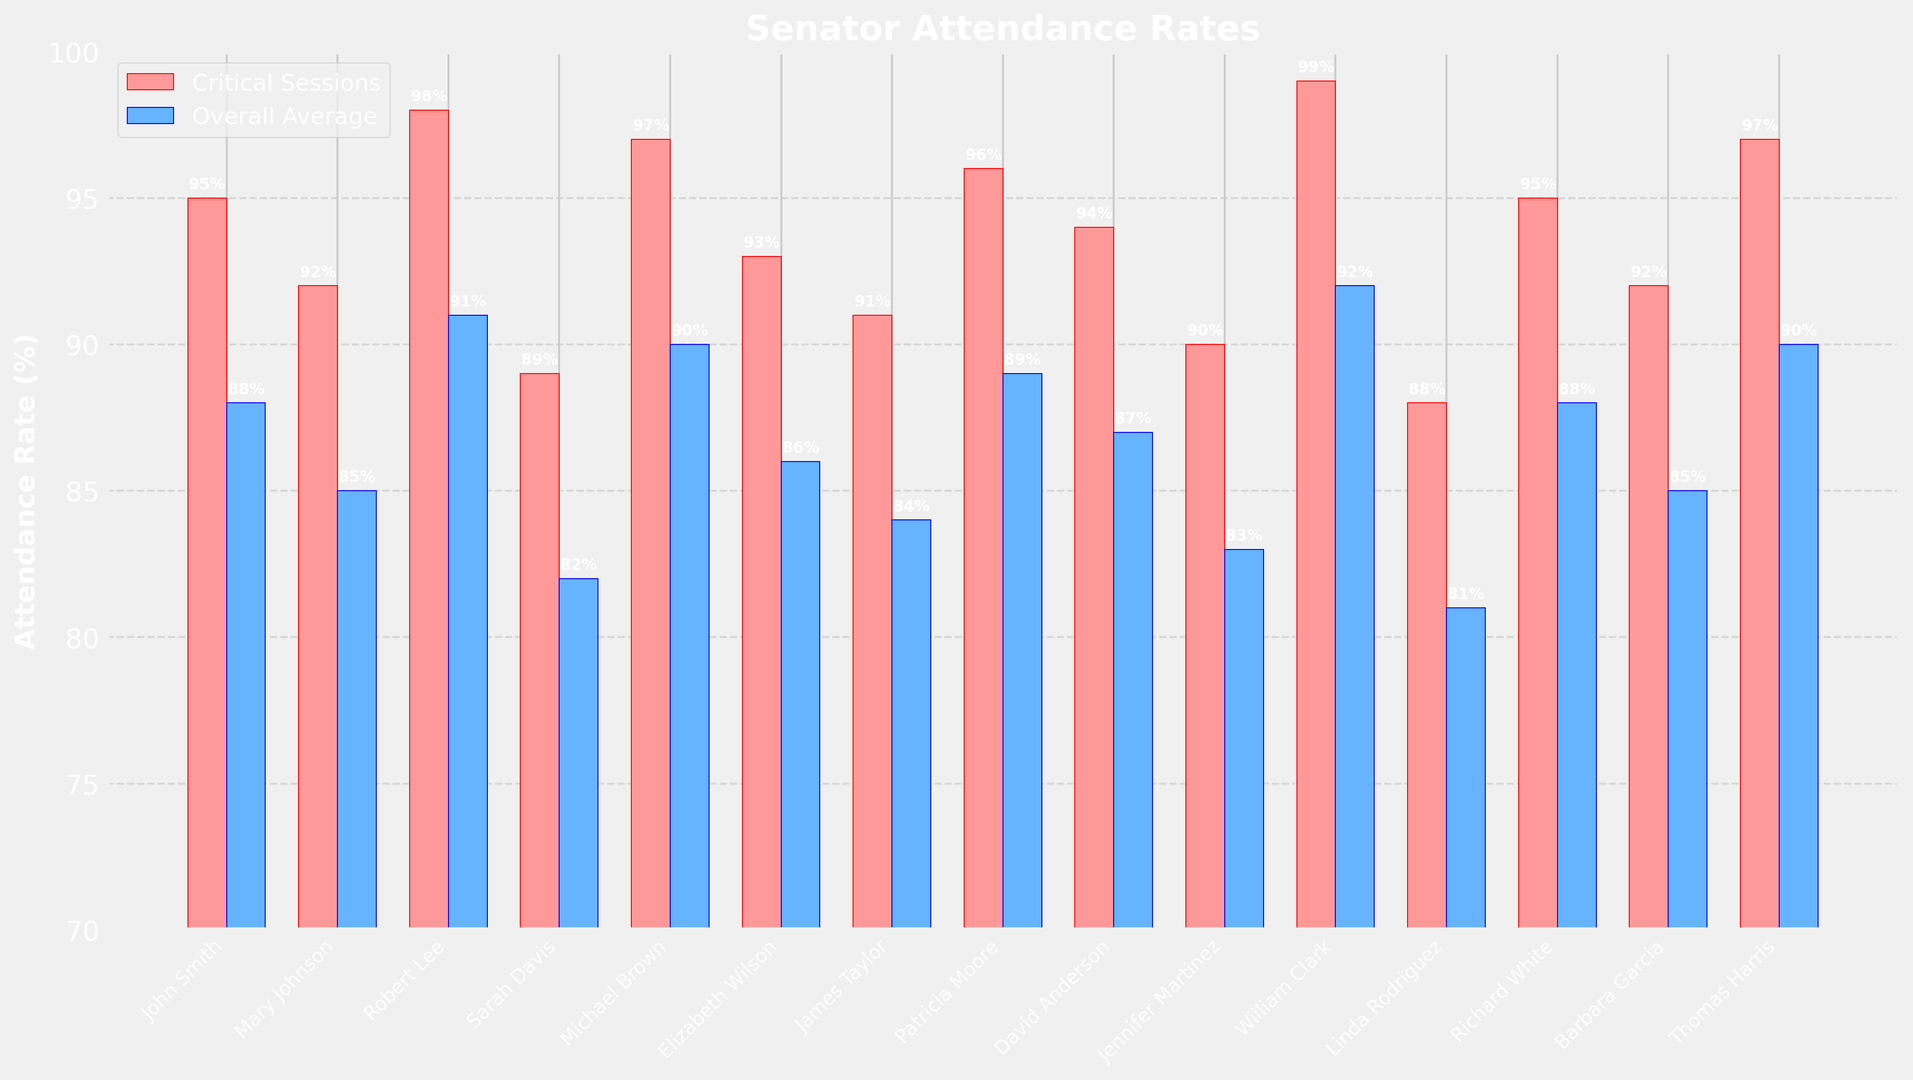Which senator has the highest attendance rate during critical sessions? The bar representing William Clark for critical sessions is the tallest among all the senators, which indicates the highest attendance rate.
Answer: William Clark What is the difference between Robert Lee's attendance rate for critical sessions and overall average? Robert Lee's attendance rate for critical sessions is 98%, and his overall average attendance rate is 91%. The difference is 98% - 91%.
Answer: 7% Who has a lower attendance rate during critical sessions, Jennifer Martinez or Linda Rodriguez? Compare the heights of the bars for Jennifer Martinez and Linda Rodriguez for critical sessions. Jennifer Martinez has an attendance rate of 90% while Linda Rodriguez has 88%.
Answer: Linda Rodriguez What is the average attendance rate during critical sessions for John Smith, Mary Johnson, and Robert Lee? The attendance rates for critical sessions are: John Smith 95%, Mary Johnson 92%, and Robert Lee 98%. Calculate the average: (95 + 92 + 98) / 3.
Answer: 95% Which senator has the largest difference between attendance rate for critical sessions and overall average? Calculate the differences for each senator and identify the largest one. William Clark has a difference of 99% - 92% = 7%.
Answer: William Clark Is Michael Brown's overall average attendance rate greater than David Anderson's attendance rate during critical sessions? Michael Brown's overall attendance rate is 90%. David Anderson's attendance rate during critical sessions is 94%. Compare the two values.
Answer: No Which senators have an attendance rate greater than 95% during critical sessions? Identify the bars taller than 95% for critical sessions: Robert Lee, Michael Brown, Patricia Moore, Thomas Harris, and William Clark.
Answer: Robert Lee, Michael Brown, Patricia Moore, Thomas Harris, William Clark Compare the attendance rates for critical sessions between James Taylor and Barbara Garcia. Identify the bars for James Taylor and Barbara Garcia. James Taylor has 91%, and Barbara Garcia has 92%. Barbara Garcia's bar is taller.
Answer: Barbara Garcia What is the combined average attendance rate for critical sessions of Richard White and Linda Rodriguez? Richard White's rate is 95%, and Linda Rodriguez's rate is 88%. Calculate the average: (95 + 88) / 2.
Answer: 91.5% Which senator's overall attendance rate is closest to their attendance rate during critical sessions? Compare the differences between the attendance rates. Richard White has both rates at 95% and 88%, so he has the closest match with a difference of 0%.
Answer: Richard White 